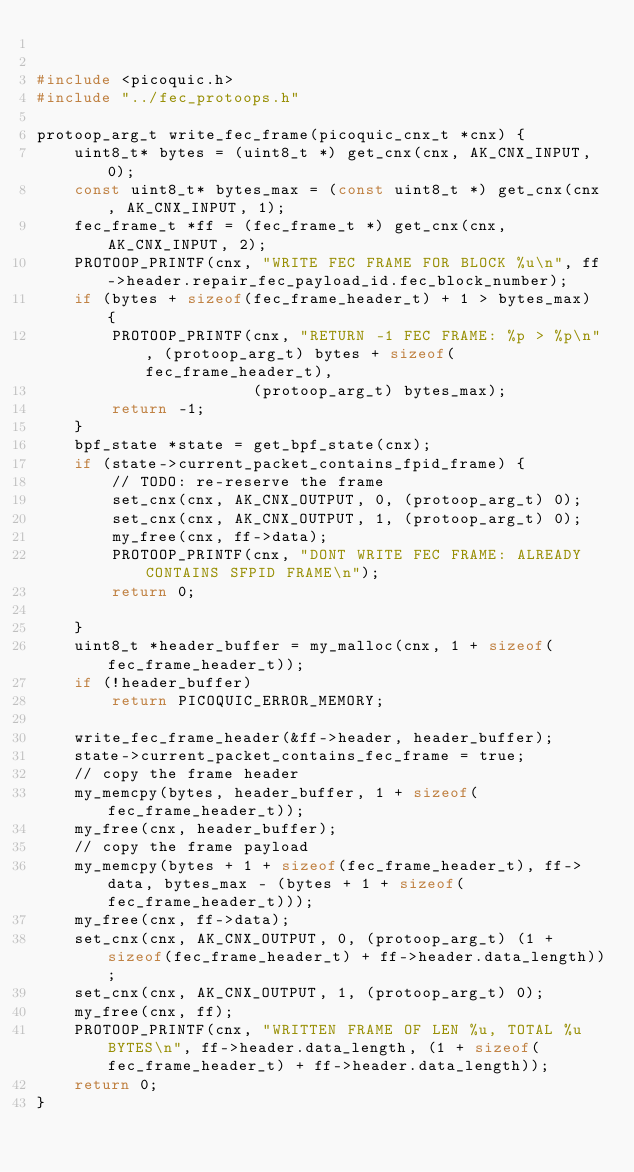<code> <loc_0><loc_0><loc_500><loc_500><_C_>

#include <picoquic.h>
#include "../fec_protoops.h"

protoop_arg_t write_fec_frame(picoquic_cnx_t *cnx) {
    uint8_t* bytes = (uint8_t *) get_cnx(cnx, AK_CNX_INPUT, 0);
    const uint8_t* bytes_max = (const uint8_t *) get_cnx(cnx, AK_CNX_INPUT, 1);
    fec_frame_t *ff = (fec_frame_t *) get_cnx(cnx, AK_CNX_INPUT, 2);
    PROTOOP_PRINTF(cnx, "WRITE FEC FRAME FOR BLOCK %u\n", ff->header.repair_fec_payload_id.fec_block_number);
    if (bytes + sizeof(fec_frame_header_t) + 1 > bytes_max) {
        PROTOOP_PRINTF(cnx, "RETURN -1 FEC FRAME: %p > %p\n", (protoop_arg_t) bytes + sizeof(fec_frame_header_t),
                       (protoop_arg_t) bytes_max);
        return -1;
    }
    bpf_state *state = get_bpf_state(cnx);
    if (state->current_packet_contains_fpid_frame) {
        // TODO: re-reserve the frame
        set_cnx(cnx, AK_CNX_OUTPUT, 0, (protoop_arg_t) 0);
        set_cnx(cnx, AK_CNX_OUTPUT, 1, (protoop_arg_t) 0);
        my_free(cnx, ff->data);
        PROTOOP_PRINTF(cnx, "DONT WRITE FEC FRAME: ALREADY CONTAINS SFPID FRAME\n");
        return 0;

    }
    uint8_t *header_buffer = my_malloc(cnx, 1 + sizeof(fec_frame_header_t));
    if (!header_buffer)
        return PICOQUIC_ERROR_MEMORY;

    write_fec_frame_header(&ff->header, header_buffer);
    state->current_packet_contains_fec_frame = true;
    // copy the frame header
    my_memcpy(bytes, header_buffer, 1 + sizeof(fec_frame_header_t));
    my_free(cnx, header_buffer);
    // copy the frame payload
    my_memcpy(bytes + 1 + sizeof(fec_frame_header_t), ff->data, bytes_max - (bytes + 1 + sizeof(fec_frame_header_t)));
    my_free(cnx, ff->data);
    set_cnx(cnx, AK_CNX_OUTPUT, 0, (protoop_arg_t) (1 + sizeof(fec_frame_header_t) + ff->header.data_length));
    set_cnx(cnx, AK_CNX_OUTPUT, 1, (protoop_arg_t) 0);
    my_free(cnx, ff);
    PROTOOP_PRINTF(cnx, "WRITTEN FRAME OF LEN %u, TOTAL %u BYTES\n", ff->header.data_length, (1 + sizeof(fec_frame_header_t) + ff->header.data_length));
    return 0;
}</code> 